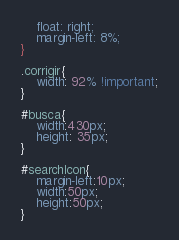<code> <loc_0><loc_0><loc_500><loc_500><_CSS_>    float: right;
    margin-left: 8%;
}

.corrigir{
    width: 92% !important;
}

#busca{
    width:430px;
    height: 35px;
}

#searchIcon{
    margin-left:10px;
    width:50px;
    height:50px;
}</code> 